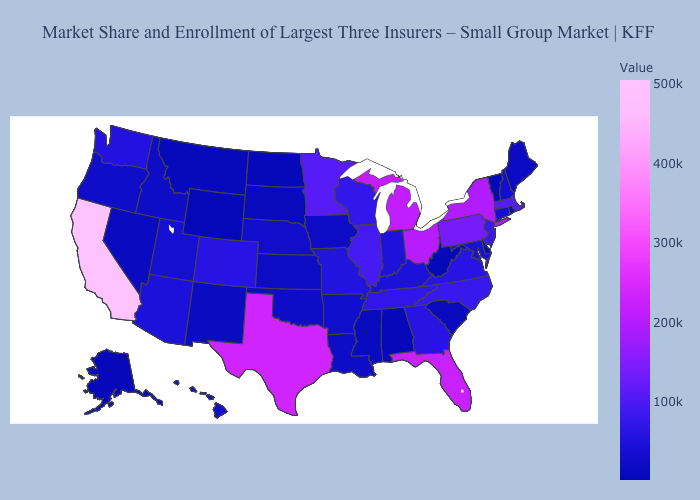Which states hav the highest value in the West?
Give a very brief answer. California. Which states have the lowest value in the South?
Quick response, please. Alabama. Is the legend a continuous bar?
Quick response, please. Yes. Which states have the lowest value in the South?
Quick response, please. Alabama. 